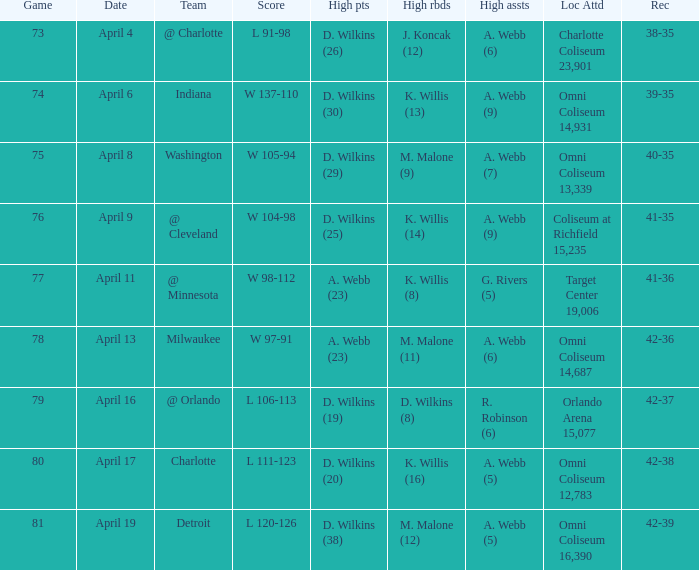What date was the game score w 104-98? April 9. 